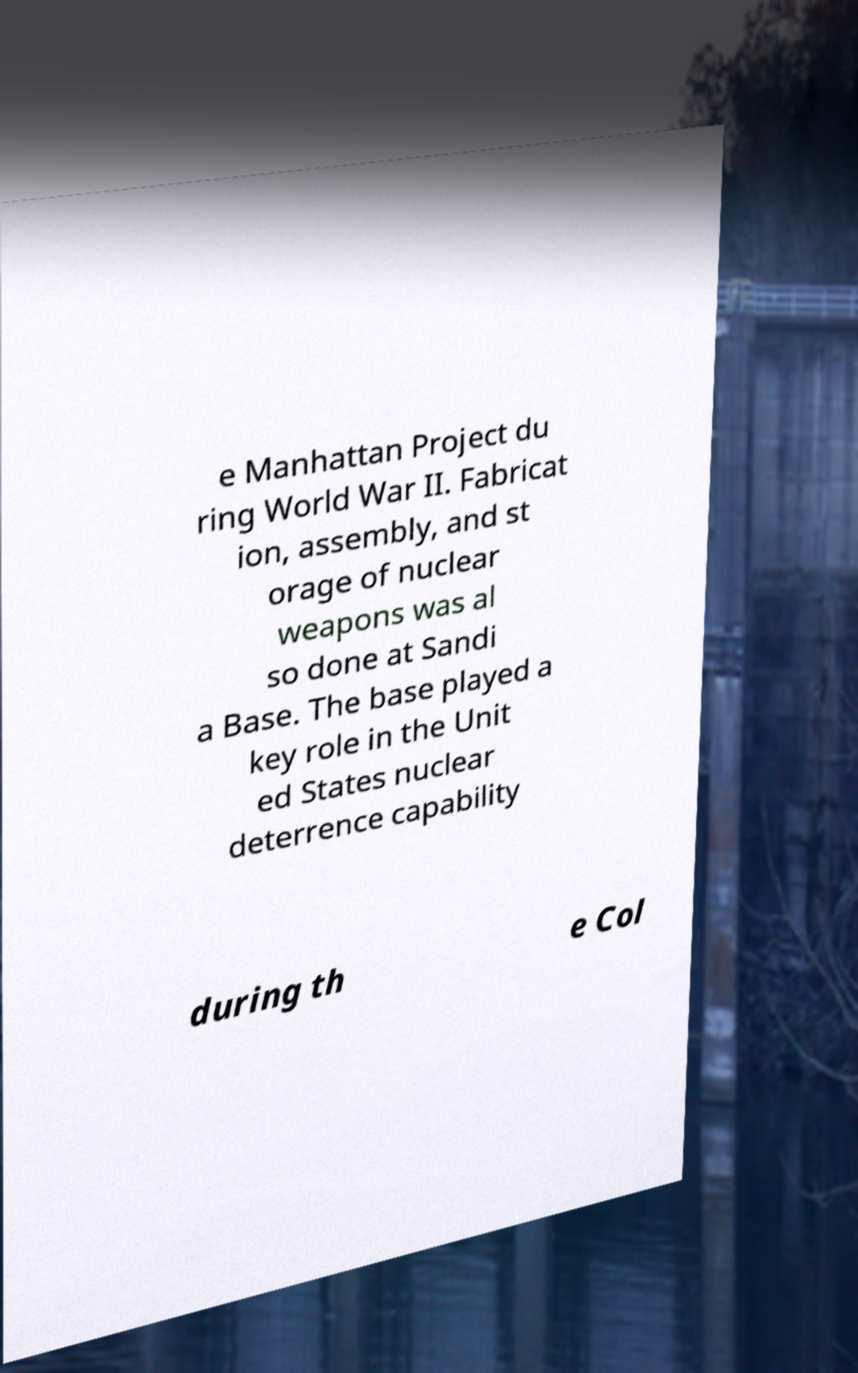Can you accurately transcribe the text from the provided image for me? e Manhattan Project du ring World War II. Fabricat ion, assembly, and st orage of nuclear weapons was al so done at Sandi a Base. The base played a key role in the Unit ed States nuclear deterrence capability during th e Col 